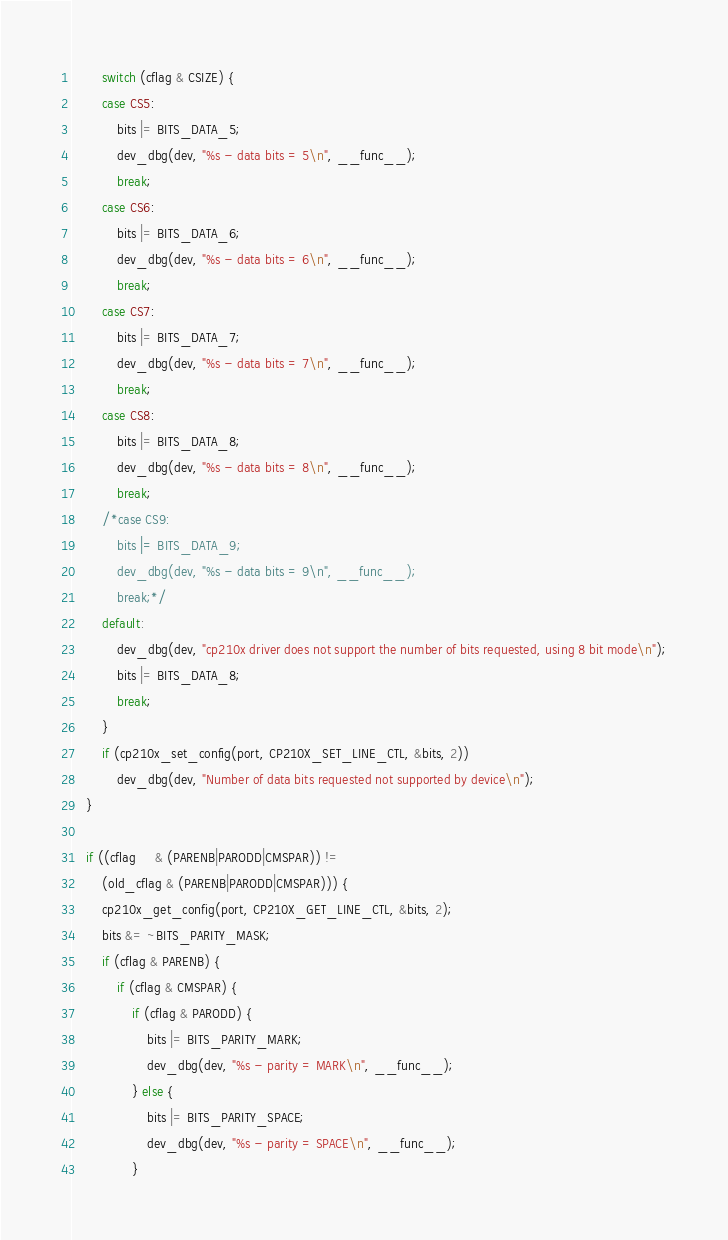Convert code to text. <code><loc_0><loc_0><loc_500><loc_500><_C_>		switch (cflag & CSIZE) {
		case CS5:
			bits |= BITS_DATA_5;
			dev_dbg(dev, "%s - data bits = 5\n", __func__);
			break;
		case CS6:
			bits |= BITS_DATA_6;
			dev_dbg(dev, "%s - data bits = 6\n", __func__);
			break;
		case CS7:
			bits |= BITS_DATA_7;
			dev_dbg(dev, "%s - data bits = 7\n", __func__);
			break;
		case CS8:
			bits |= BITS_DATA_8;
			dev_dbg(dev, "%s - data bits = 8\n", __func__);
			break;
		/*case CS9:
			bits |= BITS_DATA_9;
			dev_dbg(dev, "%s - data bits = 9\n", __func__);
			break;*/
		default:
			dev_dbg(dev, "cp210x driver does not support the number of bits requested, using 8 bit mode\n");
			bits |= BITS_DATA_8;
			break;
		}
		if (cp210x_set_config(port, CP210X_SET_LINE_CTL, &bits, 2))
			dev_dbg(dev, "Number of data bits requested not supported by device\n");
	}

	if ((cflag     & (PARENB|PARODD|CMSPAR)) !=
	    (old_cflag & (PARENB|PARODD|CMSPAR))) {
		cp210x_get_config(port, CP210X_GET_LINE_CTL, &bits, 2);
		bits &= ~BITS_PARITY_MASK;
		if (cflag & PARENB) {
			if (cflag & CMSPAR) {
				if (cflag & PARODD) {
					bits |= BITS_PARITY_MARK;
					dev_dbg(dev, "%s - parity = MARK\n", __func__);
				} else {
					bits |= BITS_PARITY_SPACE;
					dev_dbg(dev, "%s - parity = SPACE\n", __func__);
				}</code> 